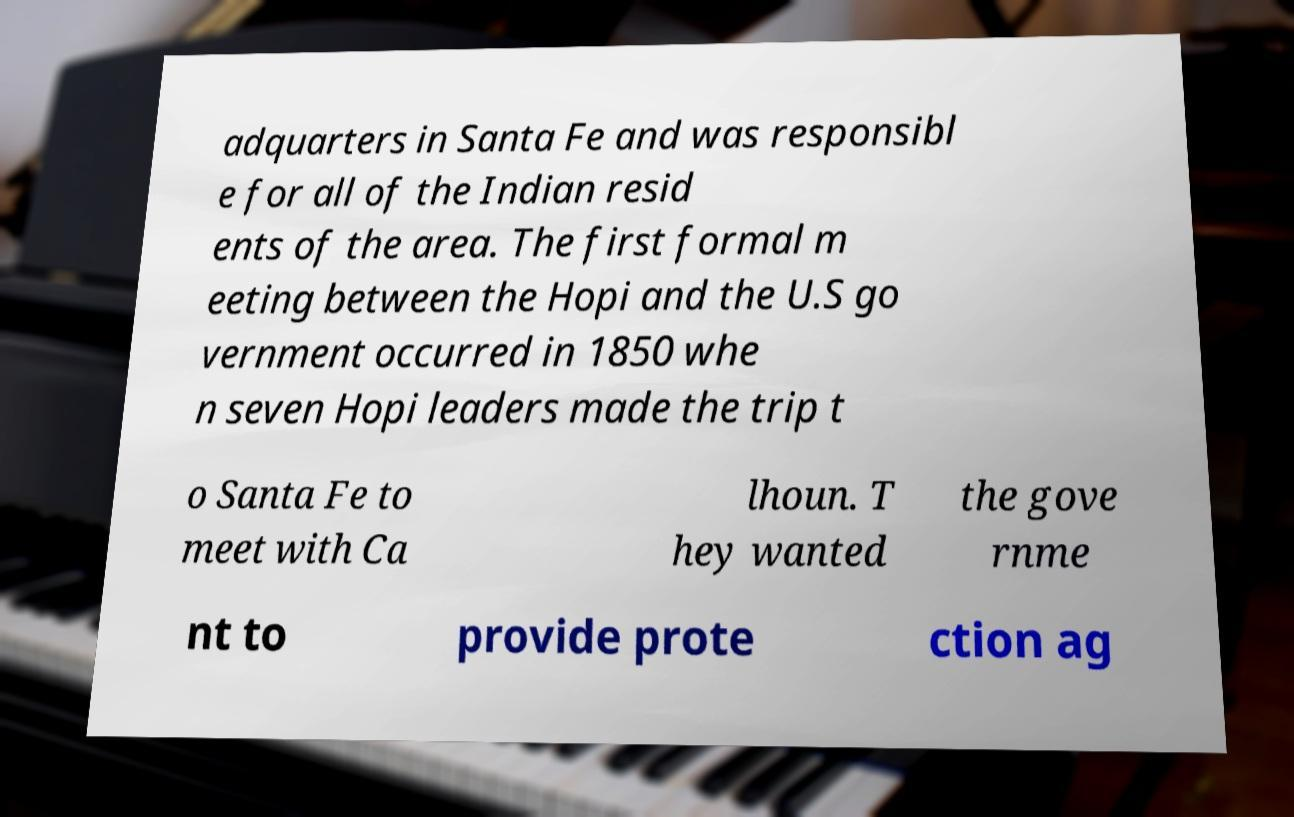There's text embedded in this image that I need extracted. Can you transcribe it verbatim? adquarters in Santa Fe and was responsibl e for all of the Indian resid ents of the area. The first formal m eeting between the Hopi and the U.S go vernment occurred in 1850 whe n seven Hopi leaders made the trip t o Santa Fe to meet with Ca lhoun. T hey wanted the gove rnme nt to provide prote ction ag 